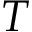<formula> <loc_0><loc_0><loc_500><loc_500>T</formula> 